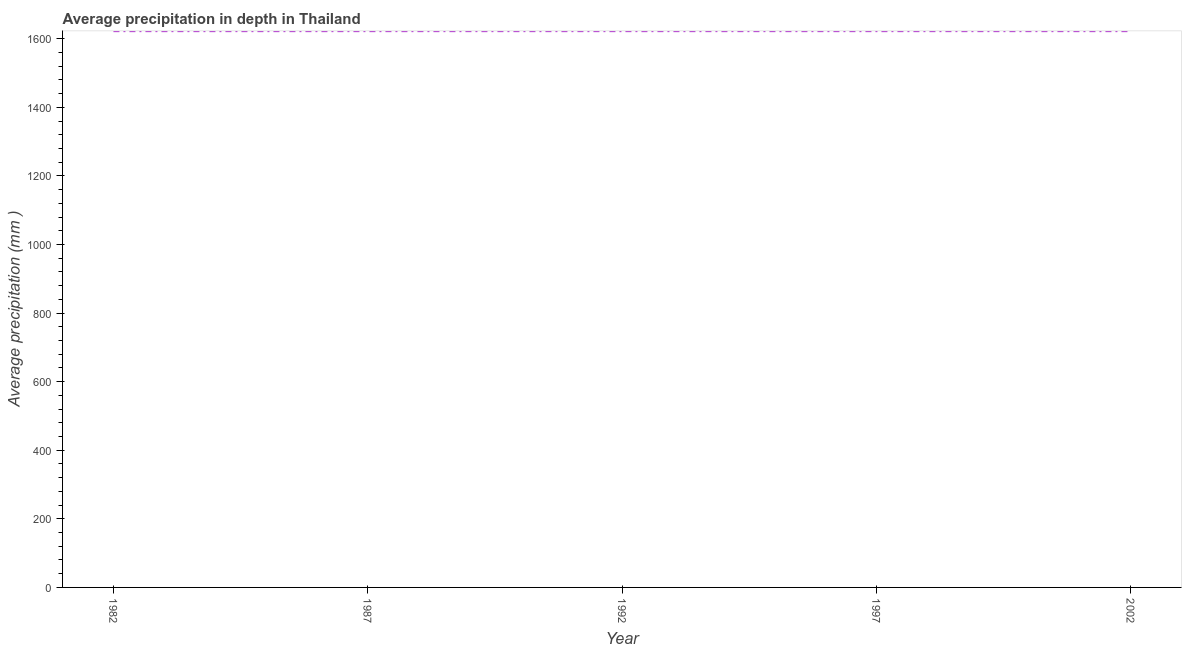What is the average precipitation in depth in 1992?
Give a very brief answer. 1622. Across all years, what is the maximum average precipitation in depth?
Provide a succinct answer. 1622. Across all years, what is the minimum average precipitation in depth?
Your response must be concise. 1622. In which year was the average precipitation in depth maximum?
Provide a short and direct response. 1982. In which year was the average precipitation in depth minimum?
Your answer should be very brief. 1982. What is the sum of the average precipitation in depth?
Provide a short and direct response. 8110. What is the difference between the average precipitation in depth in 1992 and 2002?
Give a very brief answer. 0. What is the average average precipitation in depth per year?
Your answer should be very brief. 1622. What is the median average precipitation in depth?
Keep it short and to the point. 1622. Do a majority of the years between 2002 and 1992 (inclusive) have average precipitation in depth greater than 1480 mm?
Provide a short and direct response. No. What is the ratio of the average precipitation in depth in 1997 to that in 2002?
Provide a succinct answer. 1. Is the difference between the average precipitation in depth in 1982 and 1992 greater than the difference between any two years?
Provide a succinct answer. Yes. What is the difference between the highest and the second highest average precipitation in depth?
Provide a succinct answer. 0. What is the difference between the highest and the lowest average precipitation in depth?
Give a very brief answer. 0. In how many years, is the average precipitation in depth greater than the average average precipitation in depth taken over all years?
Give a very brief answer. 0. How many years are there in the graph?
Your answer should be very brief. 5. What is the difference between two consecutive major ticks on the Y-axis?
Provide a succinct answer. 200. Does the graph contain any zero values?
Ensure brevity in your answer.  No. What is the title of the graph?
Your response must be concise. Average precipitation in depth in Thailand. What is the label or title of the X-axis?
Offer a very short reply. Year. What is the label or title of the Y-axis?
Offer a terse response. Average precipitation (mm ). What is the Average precipitation (mm ) in 1982?
Offer a terse response. 1622. What is the Average precipitation (mm ) in 1987?
Your response must be concise. 1622. What is the Average precipitation (mm ) in 1992?
Offer a very short reply. 1622. What is the Average precipitation (mm ) in 1997?
Your answer should be compact. 1622. What is the Average precipitation (mm ) in 2002?
Keep it short and to the point. 1622. What is the difference between the Average precipitation (mm ) in 1982 and 1992?
Offer a terse response. 0. What is the difference between the Average precipitation (mm ) in 1982 and 2002?
Your answer should be compact. 0. What is the difference between the Average precipitation (mm ) in 1997 and 2002?
Your response must be concise. 0. What is the ratio of the Average precipitation (mm ) in 1982 to that in 1992?
Keep it short and to the point. 1. What is the ratio of the Average precipitation (mm ) in 1982 to that in 1997?
Offer a terse response. 1. What is the ratio of the Average precipitation (mm ) in 1987 to that in 1992?
Your answer should be very brief. 1. 